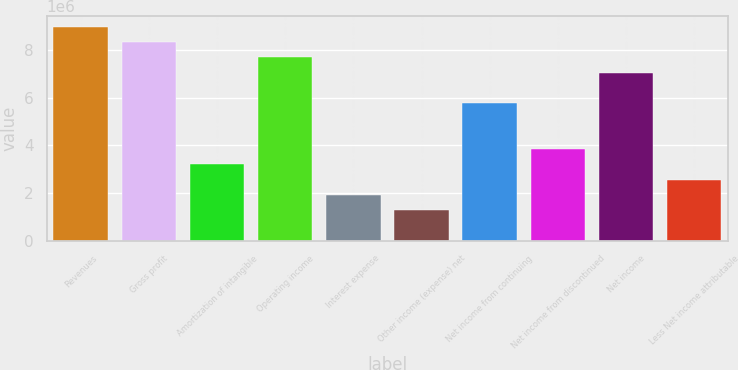Convert chart to OTSL. <chart><loc_0><loc_0><loc_500><loc_500><bar_chart><fcel>Revenues<fcel>Gross profit<fcel>Amortization of intangible<fcel>Operating income<fcel>Interest expense<fcel>Other income (expense) net<fcel>Net income from continuing<fcel>Net income from discontinued<fcel>Net income<fcel>Less Net income attributable<nl><fcel>8.97621e+06<fcel>8.33505e+06<fcel>3.20579e+06<fcel>7.69389e+06<fcel>1.92347e+06<fcel>1.28232e+06<fcel>5.77042e+06<fcel>3.84695e+06<fcel>7.05273e+06<fcel>2.56463e+06<nl></chart> 